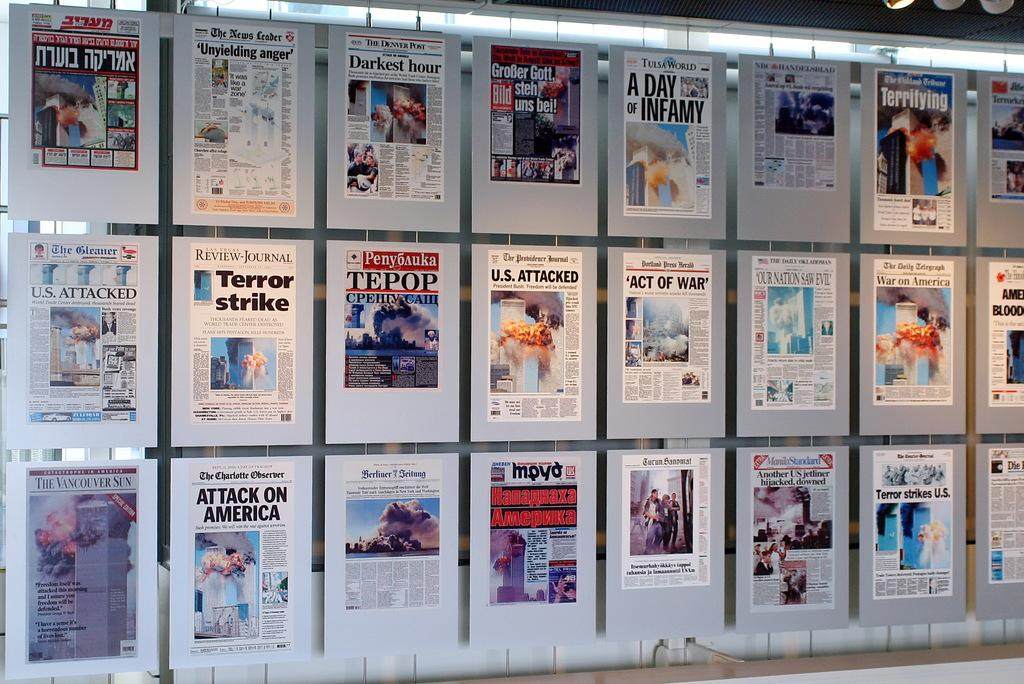<image>
Create a compact narrative representing the image presented. A wall of newspaper headlines, one of which reads Attack on America. 